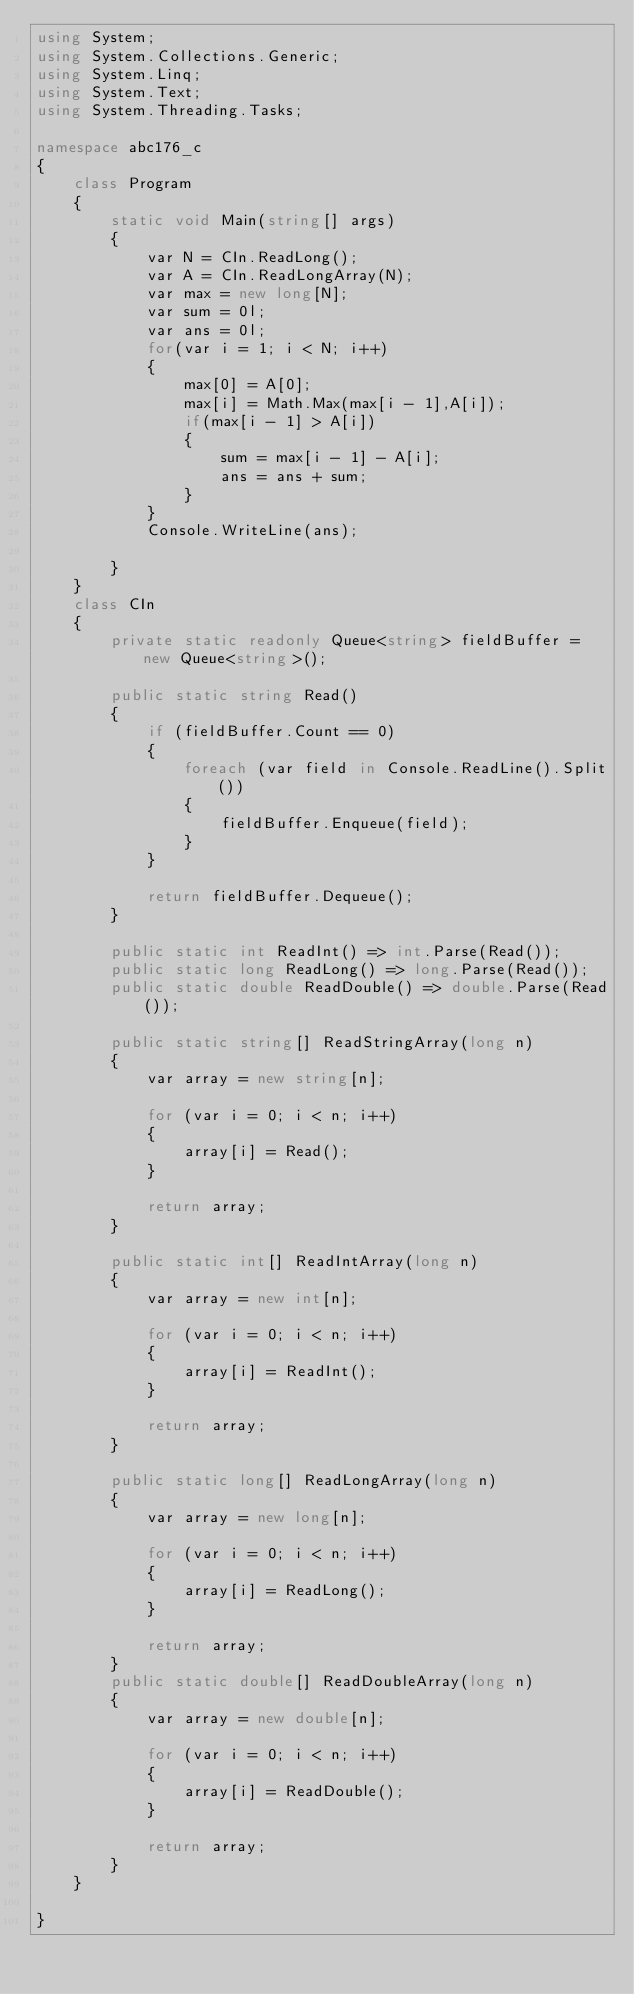<code> <loc_0><loc_0><loc_500><loc_500><_C#_>using System;
using System.Collections.Generic;
using System.Linq;
using System.Text;
using System.Threading.Tasks;

namespace abc176_c
{
    class Program
    {
        static void Main(string[] args)
        {
            var N = CIn.ReadLong();
            var A = CIn.ReadLongArray(N);
            var max = new long[N];
            var sum = 0l;
            var ans = 0l;
            for(var i = 1; i < N; i++)
            {
                max[0] = A[0];
                max[i] = Math.Max(max[i - 1],A[i]);
                if(max[i - 1] > A[i])
                {
                    sum = max[i - 1] - A[i];
                    ans = ans + sum;
                }
            }
            Console.WriteLine(ans);
        
        }
    }
    class CIn
    {
        private static readonly Queue<string> fieldBuffer = new Queue<string>();

        public static string Read()
        {
            if (fieldBuffer.Count == 0)
            {
                foreach (var field in Console.ReadLine().Split())
                {
                    fieldBuffer.Enqueue(field);
                }
            }

            return fieldBuffer.Dequeue();
        }

        public static int ReadInt() => int.Parse(Read());
        public static long ReadLong() => long.Parse(Read());
        public static double ReadDouble() => double.Parse(Read());

        public static string[] ReadStringArray(long n)
        {
            var array = new string[n];

            for (var i = 0; i < n; i++)
            {
                array[i] = Read();
            }

            return array;
        }

        public static int[] ReadIntArray(long n)
        {
            var array = new int[n];

            for (var i = 0; i < n; i++)
            {
                array[i] = ReadInt();
            }

            return array;
        }

        public static long[] ReadLongArray(long n)
        {
            var array = new long[n];

            for (var i = 0; i < n; i++)
            {
                array[i] = ReadLong();
            }

            return array;
        }
        public static double[] ReadDoubleArray(long n)
        {
            var array = new double[n];

            for (var i = 0; i < n; i++)
            {
                array[i] = ReadDouble();
            }

            return array;
        }
    }

}
</code> 